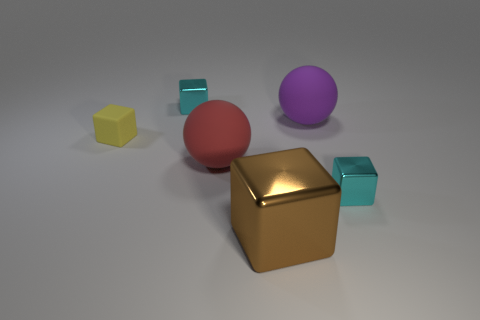There is a sphere that is the same material as the purple object; what size is it?
Offer a very short reply. Large. There is a red ball in front of the small cyan thing left of the large rubber ball that is to the right of the large brown block; what size is it?
Ensure brevity in your answer.  Large. There is a metal block that is on the right side of the big purple thing; what color is it?
Your response must be concise. Cyan. Are there more cyan cubes that are on the right side of the purple matte object than small green cylinders?
Your answer should be very brief. Yes. There is a cyan metal thing that is behind the rubber cube; does it have the same shape as the big brown metallic object?
Offer a very short reply. Yes. What number of yellow objects are either tiny matte blocks or tiny shiny things?
Provide a succinct answer. 1. Is the number of cyan metallic cubes greater than the number of big metal objects?
Provide a succinct answer. Yes. What is the color of the metal object that is the same size as the red rubber thing?
Provide a short and direct response. Brown. How many spheres are either big rubber things or large red matte things?
Give a very brief answer. 2. There is a brown object; does it have the same shape as the small object that is behind the tiny yellow cube?
Provide a short and direct response. Yes. 